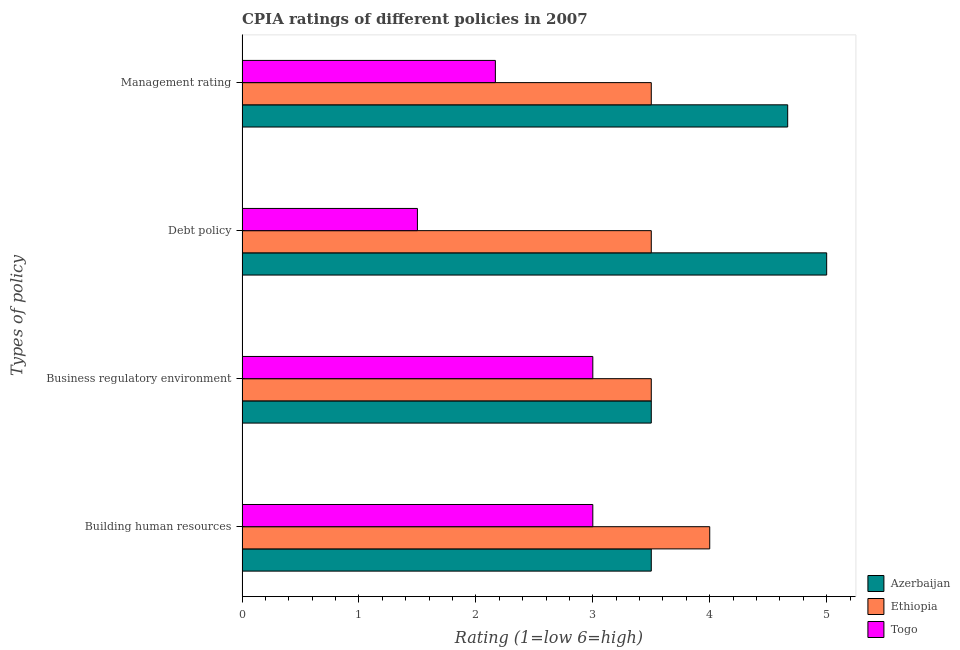How many groups of bars are there?
Make the answer very short. 4. Are the number of bars on each tick of the Y-axis equal?
Your answer should be very brief. Yes. How many bars are there on the 4th tick from the bottom?
Your answer should be compact. 3. What is the label of the 2nd group of bars from the top?
Provide a succinct answer. Debt policy. What is the cpia rating of business regulatory environment in Togo?
Your answer should be compact. 3. In which country was the cpia rating of management maximum?
Offer a terse response. Azerbaijan. In which country was the cpia rating of management minimum?
Offer a terse response. Togo. What is the total cpia rating of debt policy in the graph?
Provide a succinct answer. 10. What is the average cpia rating of management per country?
Keep it short and to the point. 3.44. What is the difference between the cpia rating of building human resources and cpia rating of management in Togo?
Your answer should be compact. 0.83. In how many countries, is the cpia rating of building human resources greater than 3.2 ?
Ensure brevity in your answer.  2. What is the ratio of the cpia rating of business regulatory environment in Togo to that in Ethiopia?
Your response must be concise. 0.86. What is the difference between the highest and the lowest cpia rating of management?
Ensure brevity in your answer.  2.5. In how many countries, is the cpia rating of building human resources greater than the average cpia rating of building human resources taken over all countries?
Your answer should be very brief. 1. Is the sum of the cpia rating of building human resources in Azerbaijan and Ethiopia greater than the maximum cpia rating of business regulatory environment across all countries?
Provide a succinct answer. Yes. What does the 1st bar from the top in Building human resources represents?
Ensure brevity in your answer.  Togo. What does the 1st bar from the bottom in Building human resources represents?
Offer a very short reply. Azerbaijan. How many bars are there?
Offer a very short reply. 12. How many countries are there in the graph?
Ensure brevity in your answer.  3. What is the difference between two consecutive major ticks on the X-axis?
Give a very brief answer. 1. Does the graph contain any zero values?
Your answer should be compact. No. Does the graph contain grids?
Your answer should be very brief. No. What is the title of the graph?
Offer a very short reply. CPIA ratings of different policies in 2007. What is the label or title of the X-axis?
Your answer should be compact. Rating (1=low 6=high). What is the label or title of the Y-axis?
Your response must be concise. Types of policy. What is the Rating (1=low 6=high) of Ethiopia in Building human resources?
Keep it short and to the point. 4. What is the Rating (1=low 6=high) of Togo in Building human resources?
Your answer should be very brief. 3. What is the Rating (1=low 6=high) of Ethiopia in Business regulatory environment?
Your answer should be compact. 3.5. What is the Rating (1=low 6=high) of Togo in Business regulatory environment?
Your response must be concise. 3. What is the Rating (1=low 6=high) of Azerbaijan in Debt policy?
Offer a very short reply. 5. What is the Rating (1=low 6=high) in Togo in Debt policy?
Offer a terse response. 1.5. What is the Rating (1=low 6=high) in Azerbaijan in Management rating?
Offer a very short reply. 4.67. What is the Rating (1=low 6=high) of Togo in Management rating?
Make the answer very short. 2.17. Across all Types of policy, what is the maximum Rating (1=low 6=high) of Togo?
Keep it short and to the point. 3. Across all Types of policy, what is the minimum Rating (1=low 6=high) in Ethiopia?
Give a very brief answer. 3.5. What is the total Rating (1=low 6=high) in Azerbaijan in the graph?
Provide a short and direct response. 16.67. What is the total Rating (1=low 6=high) of Ethiopia in the graph?
Offer a terse response. 14.5. What is the total Rating (1=low 6=high) of Togo in the graph?
Give a very brief answer. 9.67. What is the difference between the Rating (1=low 6=high) in Azerbaijan in Building human resources and that in Business regulatory environment?
Offer a very short reply. 0. What is the difference between the Rating (1=low 6=high) of Ethiopia in Building human resources and that in Business regulatory environment?
Give a very brief answer. 0.5. What is the difference between the Rating (1=low 6=high) in Togo in Building human resources and that in Business regulatory environment?
Ensure brevity in your answer.  0. What is the difference between the Rating (1=low 6=high) of Azerbaijan in Building human resources and that in Debt policy?
Provide a succinct answer. -1.5. What is the difference between the Rating (1=low 6=high) of Togo in Building human resources and that in Debt policy?
Provide a succinct answer. 1.5. What is the difference between the Rating (1=low 6=high) of Azerbaijan in Building human resources and that in Management rating?
Your answer should be compact. -1.17. What is the difference between the Rating (1=low 6=high) in Ethiopia in Building human resources and that in Management rating?
Provide a succinct answer. 0.5. What is the difference between the Rating (1=low 6=high) of Azerbaijan in Business regulatory environment and that in Debt policy?
Give a very brief answer. -1.5. What is the difference between the Rating (1=low 6=high) in Azerbaijan in Business regulatory environment and that in Management rating?
Provide a succinct answer. -1.17. What is the difference between the Rating (1=low 6=high) of Togo in Business regulatory environment and that in Management rating?
Provide a succinct answer. 0.83. What is the difference between the Rating (1=low 6=high) in Azerbaijan in Building human resources and the Rating (1=low 6=high) in Togo in Business regulatory environment?
Ensure brevity in your answer.  0.5. What is the difference between the Rating (1=low 6=high) in Azerbaijan in Building human resources and the Rating (1=low 6=high) in Togo in Debt policy?
Make the answer very short. 2. What is the difference between the Rating (1=low 6=high) in Azerbaijan in Building human resources and the Rating (1=low 6=high) in Togo in Management rating?
Provide a short and direct response. 1.33. What is the difference between the Rating (1=low 6=high) in Ethiopia in Building human resources and the Rating (1=low 6=high) in Togo in Management rating?
Offer a very short reply. 1.83. What is the difference between the Rating (1=low 6=high) in Azerbaijan in Business regulatory environment and the Rating (1=low 6=high) in Ethiopia in Debt policy?
Offer a very short reply. 0. What is the difference between the Rating (1=low 6=high) of Azerbaijan in Business regulatory environment and the Rating (1=low 6=high) of Togo in Debt policy?
Make the answer very short. 2. What is the difference between the Rating (1=low 6=high) in Ethiopia in Business regulatory environment and the Rating (1=low 6=high) in Togo in Debt policy?
Offer a terse response. 2. What is the difference between the Rating (1=low 6=high) in Azerbaijan in Business regulatory environment and the Rating (1=low 6=high) in Ethiopia in Management rating?
Your answer should be compact. 0. What is the difference between the Rating (1=low 6=high) in Azerbaijan in Debt policy and the Rating (1=low 6=high) in Togo in Management rating?
Your response must be concise. 2.83. What is the average Rating (1=low 6=high) in Azerbaijan per Types of policy?
Make the answer very short. 4.17. What is the average Rating (1=low 6=high) in Ethiopia per Types of policy?
Offer a very short reply. 3.62. What is the average Rating (1=low 6=high) of Togo per Types of policy?
Your answer should be very brief. 2.42. What is the difference between the Rating (1=low 6=high) of Azerbaijan and Rating (1=low 6=high) of Ethiopia in Building human resources?
Offer a terse response. -0.5. What is the difference between the Rating (1=low 6=high) in Azerbaijan and Rating (1=low 6=high) in Togo in Building human resources?
Provide a short and direct response. 0.5. What is the difference between the Rating (1=low 6=high) of Azerbaijan and Rating (1=low 6=high) of Togo in Business regulatory environment?
Offer a very short reply. 0.5. What is the difference between the Rating (1=low 6=high) in Azerbaijan and Rating (1=low 6=high) in Ethiopia in Debt policy?
Offer a terse response. 1.5. What is the difference between the Rating (1=low 6=high) of Azerbaijan and Rating (1=low 6=high) of Togo in Debt policy?
Your response must be concise. 3.5. What is the difference between the Rating (1=low 6=high) of Ethiopia and Rating (1=low 6=high) of Togo in Debt policy?
Ensure brevity in your answer.  2. What is the difference between the Rating (1=low 6=high) of Azerbaijan and Rating (1=low 6=high) of Ethiopia in Management rating?
Your answer should be very brief. 1.17. What is the ratio of the Rating (1=low 6=high) in Ethiopia in Building human resources to that in Business regulatory environment?
Your response must be concise. 1.14. What is the ratio of the Rating (1=low 6=high) in Azerbaijan in Building human resources to that in Debt policy?
Provide a succinct answer. 0.7. What is the ratio of the Rating (1=low 6=high) of Ethiopia in Building human resources to that in Debt policy?
Make the answer very short. 1.14. What is the ratio of the Rating (1=low 6=high) of Togo in Building human resources to that in Debt policy?
Give a very brief answer. 2. What is the ratio of the Rating (1=low 6=high) of Togo in Building human resources to that in Management rating?
Provide a succinct answer. 1.38. What is the ratio of the Rating (1=low 6=high) of Azerbaijan in Business regulatory environment to that in Debt policy?
Offer a terse response. 0.7. What is the ratio of the Rating (1=low 6=high) in Togo in Business regulatory environment to that in Debt policy?
Your answer should be compact. 2. What is the ratio of the Rating (1=low 6=high) of Togo in Business regulatory environment to that in Management rating?
Keep it short and to the point. 1.38. What is the ratio of the Rating (1=low 6=high) in Azerbaijan in Debt policy to that in Management rating?
Give a very brief answer. 1.07. What is the ratio of the Rating (1=low 6=high) of Ethiopia in Debt policy to that in Management rating?
Provide a succinct answer. 1. What is the ratio of the Rating (1=low 6=high) in Togo in Debt policy to that in Management rating?
Offer a terse response. 0.69. What is the difference between the highest and the second highest Rating (1=low 6=high) in Ethiopia?
Your response must be concise. 0.5. What is the difference between the highest and the lowest Rating (1=low 6=high) of Azerbaijan?
Keep it short and to the point. 1.5. What is the difference between the highest and the lowest Rating (1=low 6=high) of Ethiopia?
Offer a terse response. 0.5. 